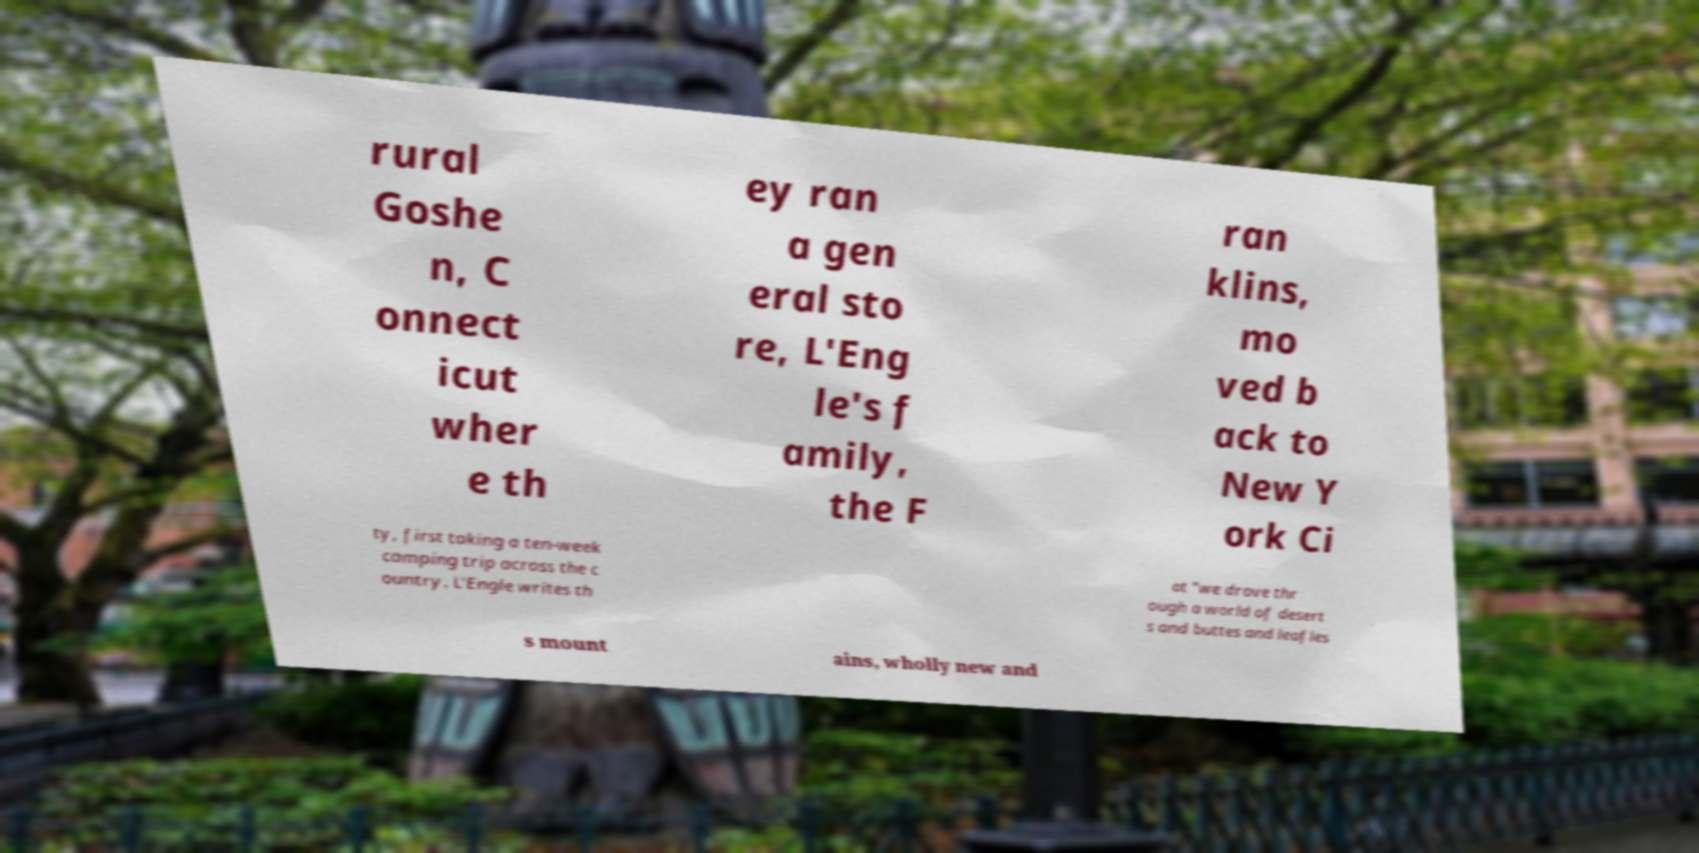Please identify and transcribe the text found in this image. rural Goshe n, C onnect icut wher e th ey ran a gen eral sto re, L'Eng le's f amily, the F ran klins, mo ved b ack to New Y ork Ci ty, first taking a ten-week camping trip across the c ountry. L'Engle writes th at "we drove thr ough a world of desert s and buttes and leafles s mount ains, wholly new and 